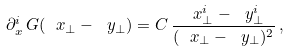<formula> <loc_0><loc_0><loc_500><loc_500>\partial _ { x } ^ { i } \, G ( \ x _ { \perp } - \ y _ { \perp } ) = C \, \frac { \ x _ { \perp } ^ { i } - \ y _ { \perp } ^ { i } } { ( \ x _ { \perp } - \ y _ { \perp } ) ^ { 2 } } \, ,</formula> 